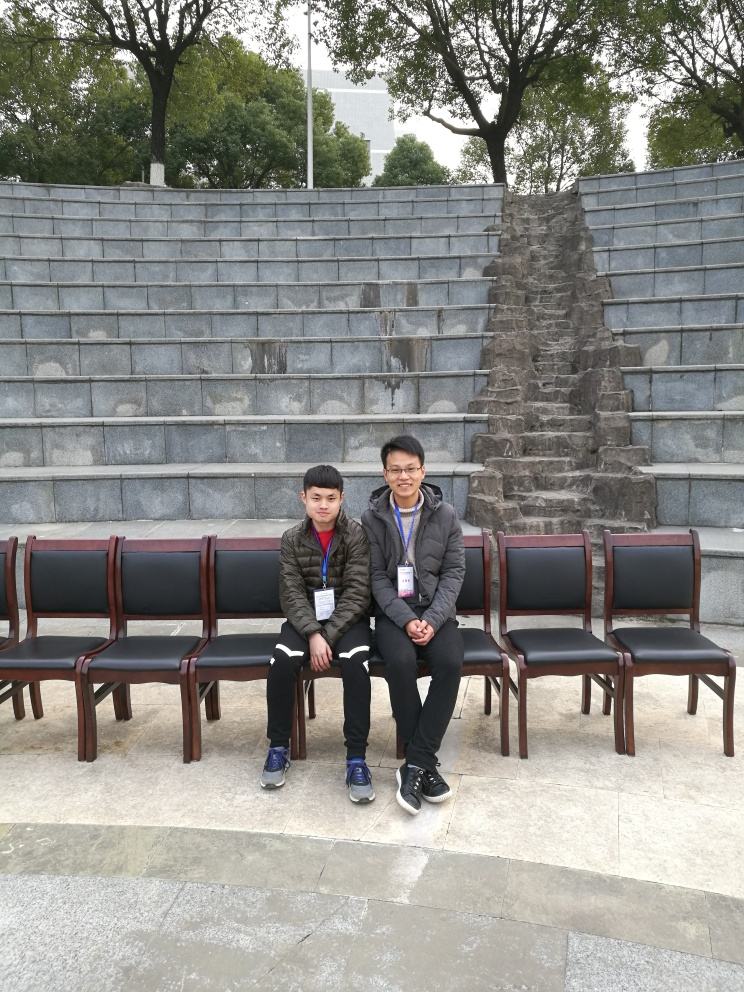How does the arrangement of chairs in the image contribute to its overall composition? The chairs create a linear pattern that guides the eye across the image, and their curved arrangement mirrors the amphitheater-like structure behind, enhancing the scene's harmony and inviting a viewer's contemplation. 